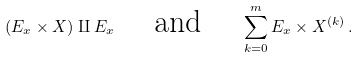Convert formula to latex. <formula><loc_0><loc_0><loc_500><loc_500>( E _ { x } \times X ) \amalg E _ { x } \quad \text { and } \quad \sum _ { k = 0 } ^ { m } E _ { x } \times X ^ { ( k ) } \, .</formula> 